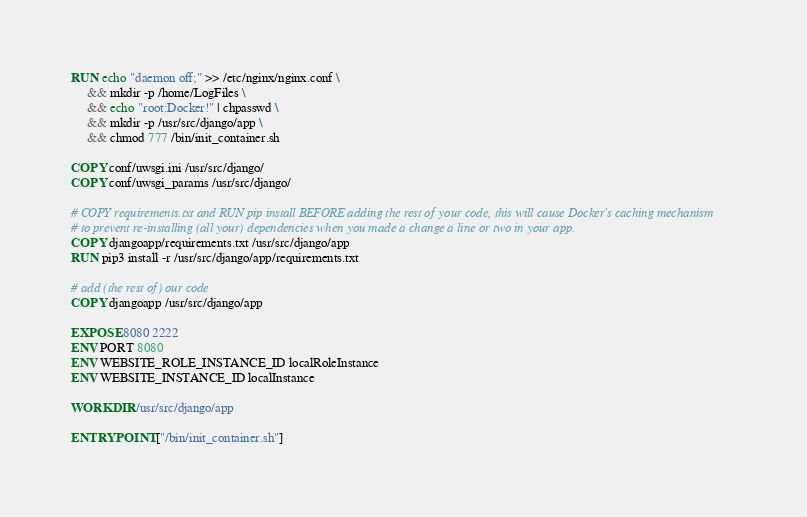<code> <loc_0><loc_0><loc_500><loc_500><_Dockerfile_>RUN echo "daemon off;" >> /etc/nginx/nginx.conf \
     && mkdir -p /home/LogFiles \
     && echo "root:Docker!" | chpasswd \
     && mkdir -p /usr/src/django/app \
     && chmod 777 /bin/init_container.sh

COPY conf/uwsgi.ini /usr/src/django/
COPY conf/uwsgi_params /usr/src/django/

# COPY requirements.txt and RUN pip install BEFORE adding the rest of your code, this will cause Docker's caching mechanism
# to prevent re-installing (all your) dependencies when you made a change a line or two in your app.
COPY djangoapp/requirements.txt /usr/src/django/app
RUN pip3 install -r /usr/src/django/app/requirements.txt

# add (the rest of) our code
COPY djangoapp /usr/src/django/app

EXPOSE 8080 2222
ENV PORT 8080
ENV WEBSITE_ROLE_INSTANCE_ID localRoleInstance
ENV WEBSITE_INSTANCE_ID localInstance

WORKDIR /usr/src/django/app

ENTRYPOINT ["/bin/init_container.sh"]
</code> 